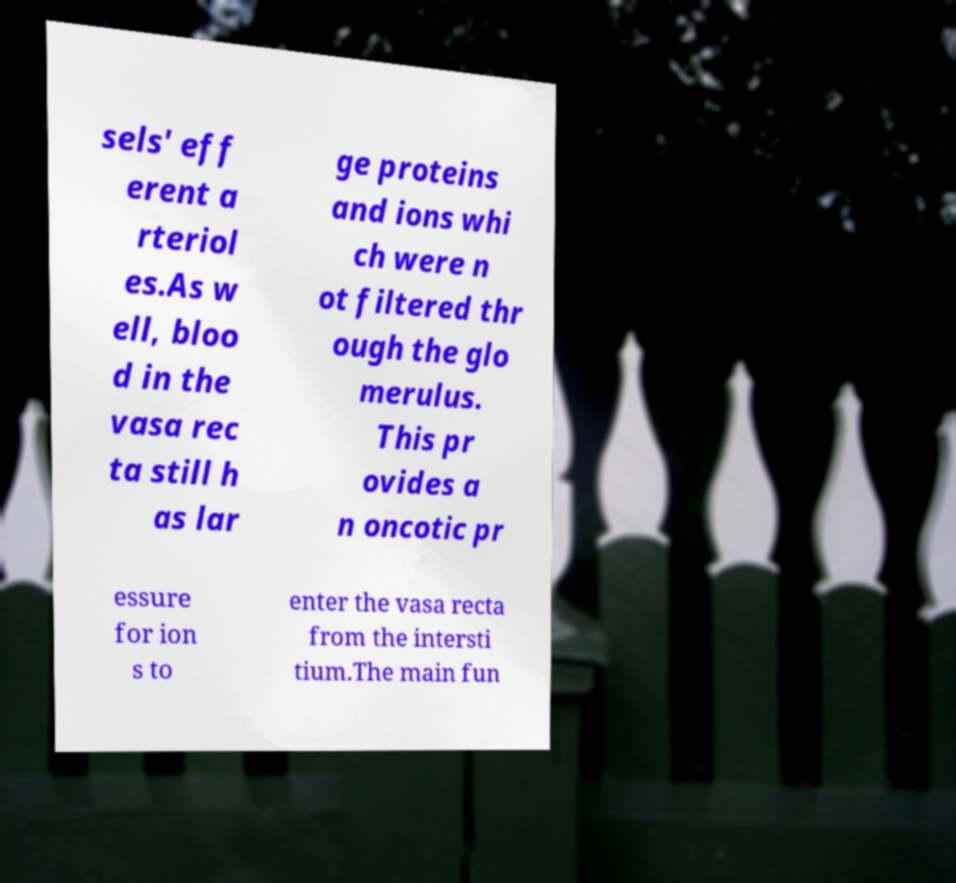What messages or text are displayed in this image? I need them in a readable, typed format. sels' eff erent a rteriol es.As w ell, bloo d in the vasa rec ta still h as lar ge proteins and ions whi ch were n ot filtered thr ough the glo merulus. This pr ovides a n oncotic pr essure for ion s to enter the vasa recta from the intersti tium.The main fun 